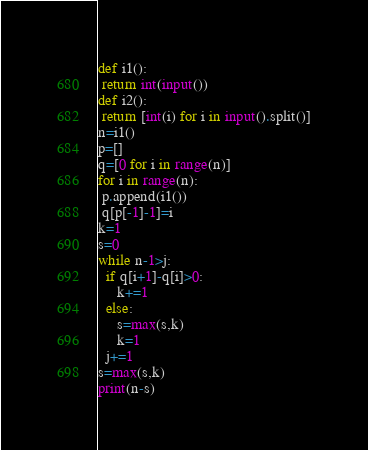Convert code to text. <code><loc_0><loc_0><loc_500><loc_500><_Python_>def i1():
 return int(input())
def i2():
 return [int(i) for i in input().split()]
n=i1()
p=[]
q=[0 for i in range(n)]
for i in range(n):   
 p.append(i1())
 q[p[-1]-1]=i
k=1
s=0
while n-1>j:
  if q[i+1]-q[i]>0:
     k+=1
  else:
     s=max(s,k)
     k=1
  j+=1
s=max(s,k)
print(n-s)</code> 